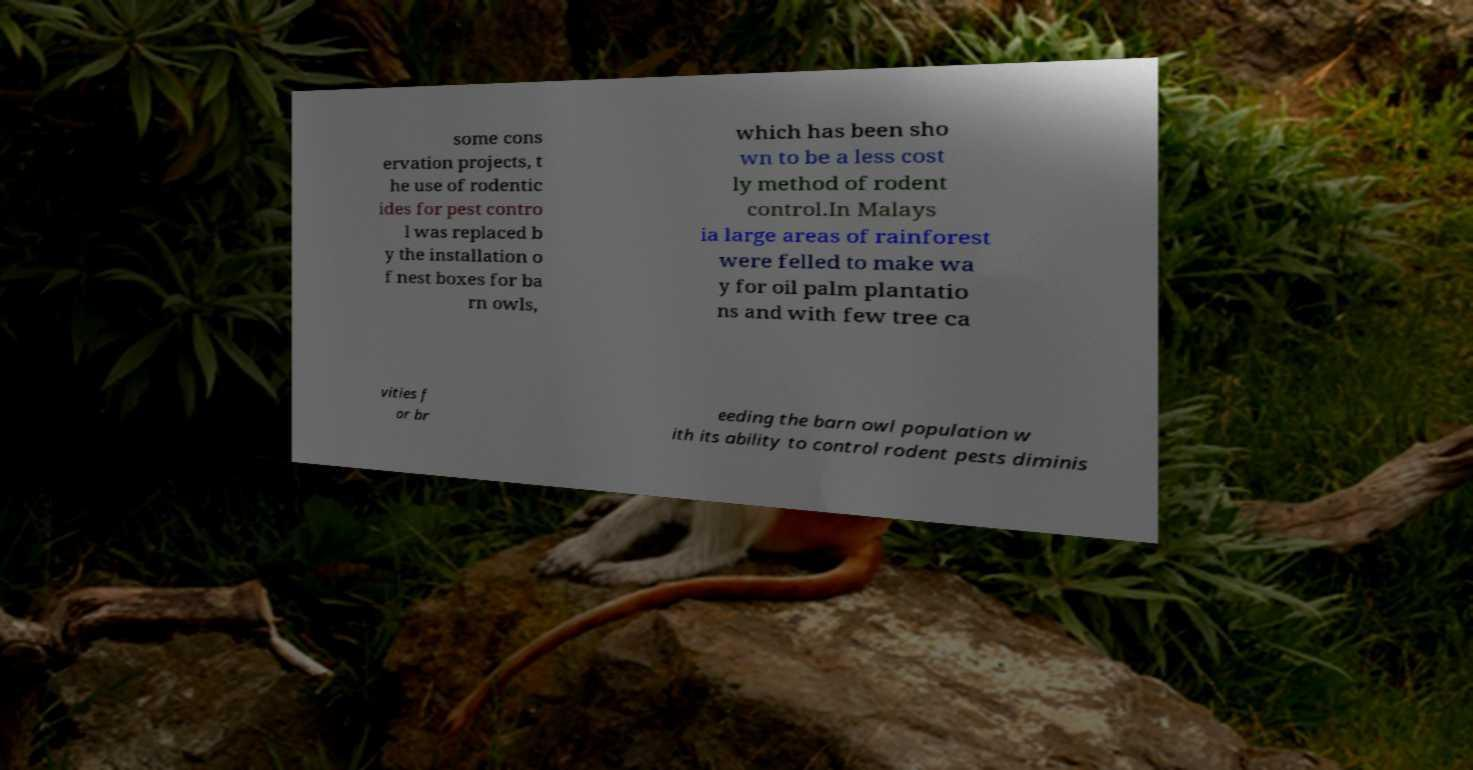Please read and relay the text visible in this image. What does it say? some cons ervation projects, t he use of rodentic ides for pest contro l was replaced b y the installation o f nest boxes for ba rn owls, which has been sho wn to be a less cost ly method of rodent control.In Malays ia large areas of rainforest were felled to make wa y for oil palm plantatio ns and with few tree ca vities f or br eeding the barn owl population w ith its ability to control rodent pests diminis 